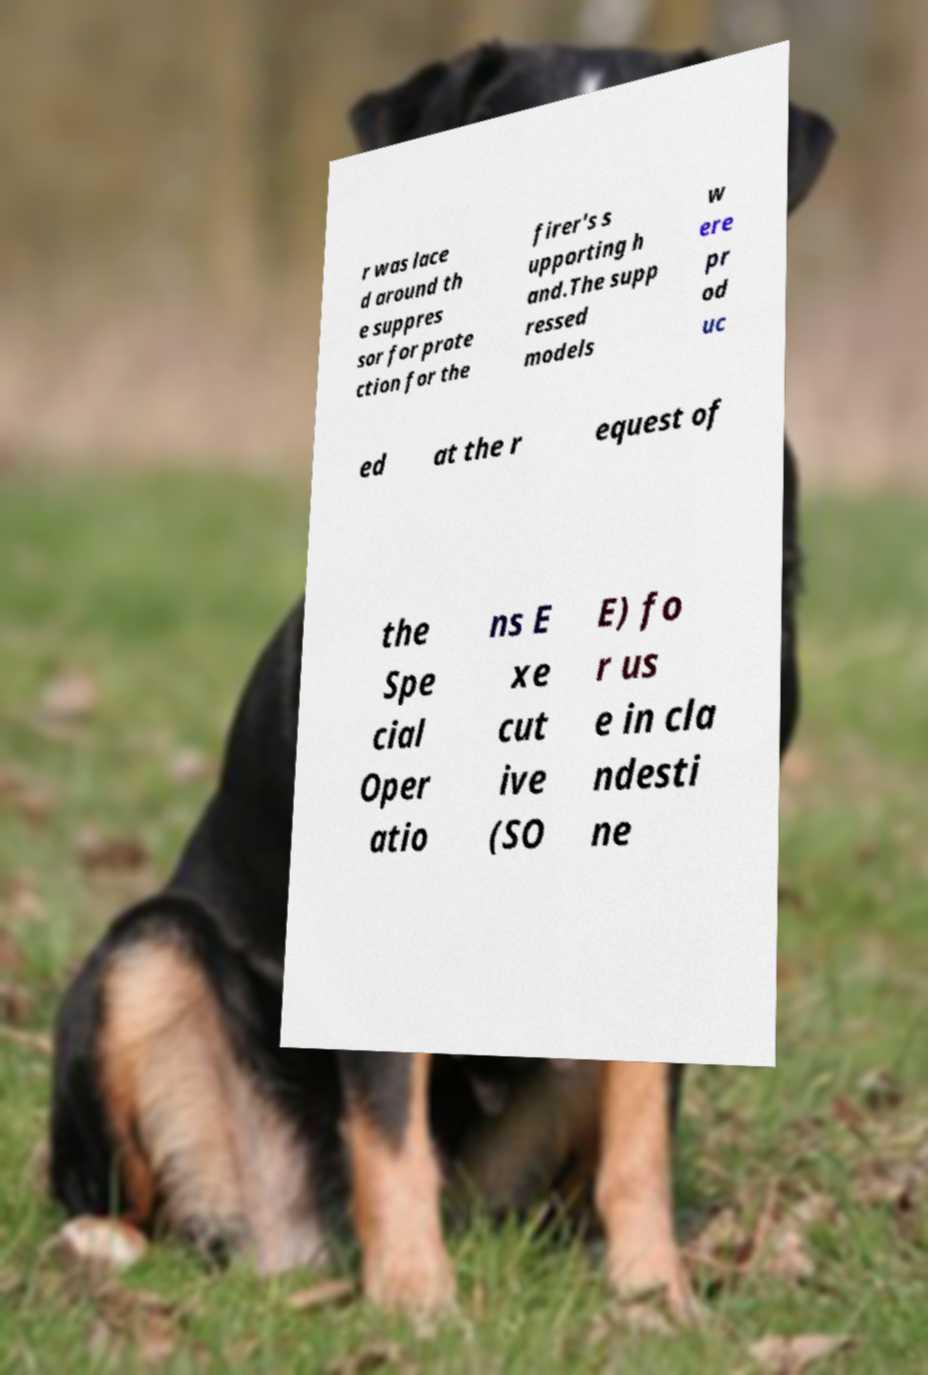Can you read and provide the text displayed in the image?This photo seems to have some interesting text. Can you extract and type it out for me? r was lace d around th e suppres sor for prote ction for the firer's s upporting h and.The supp ressed models w ere pr od uc ed at the r equest of the Spe cial Oper atio ns E xe cut ive (SO E) fo r us e in cla ndesti ne 